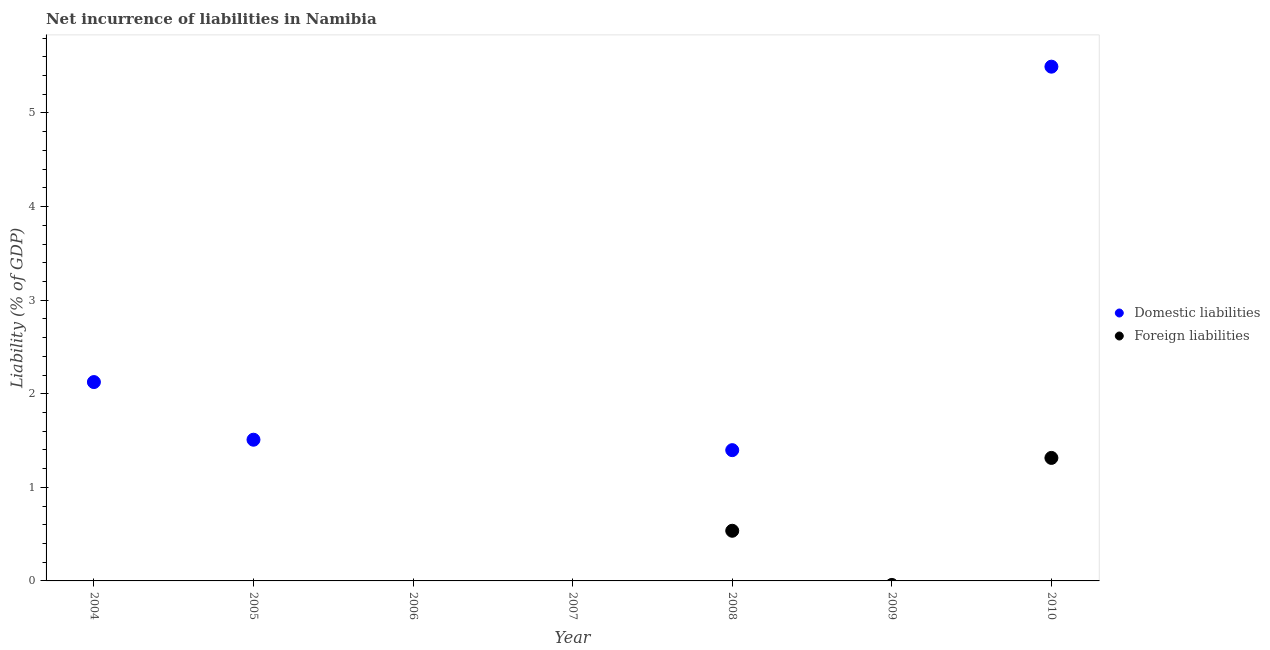How many different coloured dotlines are there?
Give a very brief answer. 2. What is the incurrence of foreign liabilities in 2004?
Your response must be concise. 0. Across all years, what is the maximum incurrence of domestic liabilities?
Your response must be concise. 5.49. What is the total incurrence of domestic liabilities in the graph?
Your answer should be very brief. 10.53. What is the difference between the incurrence of domestic liabilities in 2008 and that in 2010?
Provide a succinct answer. -4.1. What is the average incurrence of foreign liabilities per year?
Your response must be concise. 0.26. In the year 2008, what is the difference between the incurrence of domestic liabilities and incurrence of foreign liabilities?
Keep it short and to the point. 0.86. What is the difference between the highest and the second highest incurrence of domestic liabilities?
Provide a succinct answer. 3.37. What is the difference between the highest and the lowest incurrence of domestic liabilities?
Provide a succinct answer. 5.49. In how many years, is the incurrence of domestic liabilities greater than the average incurrence of domestic liabilities taken over all years?
Make the answer very short. 3. Is the incurrence of domestic liabilities strictly greater than the incurrence of foreign liabilities over the years?
Keep it short and to the point. No. Are the values on the major ticks of Y-axis written in scientific E-notation?
Give a very brief answer. No. Does the graph contain any zero values?
Offer a very short reply. Yes. Does the graph contain grids?
Give a very brief answer. No. How many legend labels are there?
Give a very brief answer. 2. What is the title of the graph?
Offer a very short reply. Net incurrence of liabilities in Namibia. What is the label or title of the X-axis?
Your answer should be very brief. Year. What is the label or title of the Y-axis?
Your answer should be very brief. Liability (% of GDP). What is the Liability (% of GDP) of Domestic liabilities in 2004?
Keep it short and to the point. 2.12. What is the Liability (% of GDP) of Foreign liabilities in 2004?
Your response must be concise. 0. What is the Liability (% of GDP) of Domestic liabilities in 2005?
Your response must be concise. 1.51. What is the Liability (% of GDP) in Foreign liabilities in 2005?
Your answer should be very brief. 0. What is the Liability (% of GDP) in Domestic liabilities in 2006?
Make the answer very short. 0. What is the Liability (% of GDP) in Domestic liabilities in 2008?
Provide a succinct answer. 1.4. What is the Liability (% of GDP) in Foreign liabilities in 2008?
Give a very brief answer. 0.54. What is the Liability (% of GDP) of Domestic liabilities in 2010?
Provide a short and direct response. 5.49. What is the Liability (% of GDP) in Foreign liabilities in 2010?
Your answer should be very brief. 1.31. Across all years, what is the maximum Liability (% of GDP) of Domestic liabilities?
Keep it short and to the point. 5.49. Across all years, what is the maximum Liability (% of GDP) in Foreign liabilities?
Offer a terse response. 1.31. Across all years, what is the minimum Liability (% of GDP) in Domestic liabilities?
Keep it short and to the point. 0. What is the total Liability (% of GDP) in Domestic liabilities in the graph?
Give a very brief answer. 10.53. What is the total Liability (% of GDP) of Foreign liabilities in the graph?
Offer a terse response. 1.85. What is the difference between the Liability (% of GDP) in Domestic liabilities in 2004 and that in 2005?
Provide a short and direct response. 0.62. What is the difference between the Liability (% of GDP) in Domestic liabilities in 2004 and that in 2008?
Ensure brevity in your answer.  0.73. What is the difference between the Liability (% of GDP) of Domestic liabilities in 2004 and that in 2010?
Provide a succinct answer. -3.37. What is the difference between the Liability (% of GDP) in Domestic liabilities in 2005 and that in 2008?
Your answer should be compact. 0.11. What is the difference between the Liability (% of GDP) in Domestic liabilities in 2005 and that in 2010?
Give a very brief answer. -3.99. What is the difference between the Liability (% of GDP) of Domestic liabilities in 2008 and that in 2010?
Make the answer very short. -4.1. What is the difference between the Liability (% of GDP) of Foreign liabilities in 2008 and that in 2010?
Provide a short and direct response. -0.78. What is the difference between the Liability (% of GDP) of Domestic liabilities in 2004 and the Liability (% of GDP) of Foreign liabilities in 2008?
Your answer should be compact. 1.59. What is the difference between the Liability (% of GDP) in Domestic liabilities in 2004 and the Liability (% of GDP) in Foreign liabilities in 2010?
Your answer should be compact. 0.81. What is the difference between the Liability (% of GDP) in Domestic liabilities in 2005 and the Liability (% of GDP) in Foreign liabilities in 2008?
Your response must be concise. 0.97. What is the difference between the Liability (% of GDP) in Domestic liabilities in 2005 and the Liability (% of GDP) in Foreign liabilities in 2010?
Your answer should be very brief. 0.19. What is the difference between the Liability (% of GDP) in Domestic liabilities in 2008 and the Liability (% of GDP) in Foreign liabilities in 2010?
Offer a terse response. 0.08. What is the average Liability (% of GDP) in Domestic liabilities per year?
Make the answer very short. 1.5. What is the average Liability (% of GDP) of Foreign liabilities per year?
Give a very brief answer. 0.26. In the year 2008, what is the difference between the Liability (% of GDP) in Domestic liabilities and Liability (% of GDP) in Foreign liabilities?
Your response must be concise. 0.86. In the year 2010, what is the difference between the Liability (% of GDP) of Domestic liabilities and Liability (% of GDP) of Foreign liabilities?
Provide a short and direct response. 4.18. What is the ratio of the Liability (% of GDP) of Domestic liabilities in 2004 to that in 2005?
Provide a short and direct response. 1.41. What is the ratio of the Liability (% of GDP) of Domestic liabilities in 2004 to that in 2008?
Your answer should be compact. 1.52. What is the ratio of the Liability (% of GDP) in Domestic liabilities in 2004 to that in 2010?
Offer a terse response. 0.39. What is the ratio of the Liability (% of GDP) of Domestic liabilities in 2005 to that in 2008?
Your answer should be compact. 1.08. What is the ratio of the Liability (% of GDP) of Domestic liabilities in 2005 to that in 2010?
Offer a terse response. 0.27. What is the ratio of the Liability (% of GDP) of Domestic liabilities in 2008 to that in 2010?
Keep it short and to the point. 0.25. What is the ratio of the Liability (% of GDP) in Foreign liabilities in 2008 to that in 2010?
Keep it short and to the point. 0.41. What is the difference between the highest and the second highest Liability (% of GDP) of Domestic liabilities?
Give a very brief answer. 3.37. What is the difference between the highest and the lowest Liability (% of GDP) of Domestic liabilities?
Offer a terse response. 5.49. What is the difference between the highest and the lowest Liability (% of GDP) in Foreign liabilities?
Your answer should be compact. 1.31. 